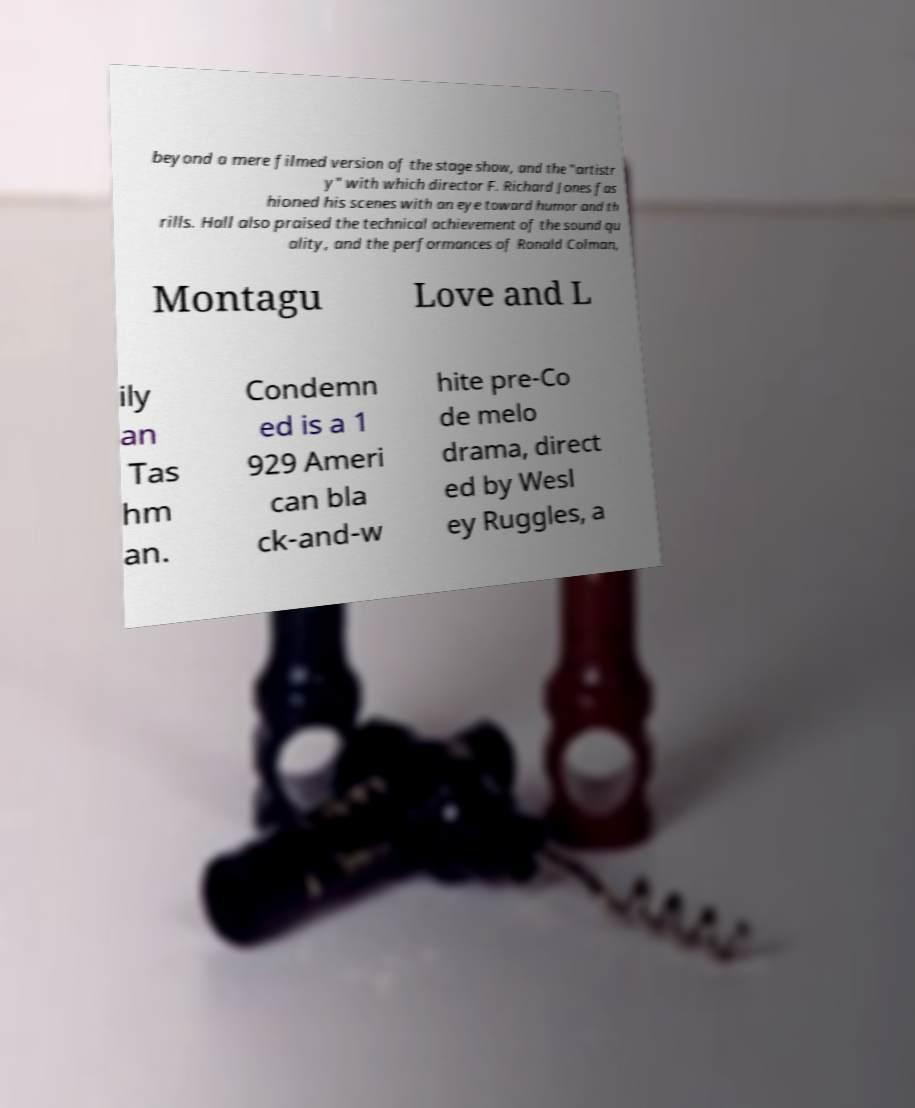Could you assist in decoding the text presented in this image and type it out clearly? beyond a mere filmed version of the stage show, and the "artistr y" with which director F. Richard Jones fas hioned his scenes with an eye toward humor and th rills. Hall also praised the technical achievement of the sound qu ality, and the performances of Ronald Colman, Montagu Love and L ily an Tas hm an. Condemn ed is a 1 929 Ameri can bla ck-and-w hite pre-Co de melo drama, direct ed by Wesl ey Ruggles, a 